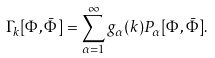Convert formula to latex. <formula><loc_0><loc_0><loc_500><loc_500>\Gamma _ { k } [ \Phi , { \bar { \Phi } } ] = \sum _ { \alpha = 1 } ^ { \infty } g _ { \alpha } ( k ) P _ { \alpha } [ \Phi , { \bar { \Phi } } ] .</formula> 